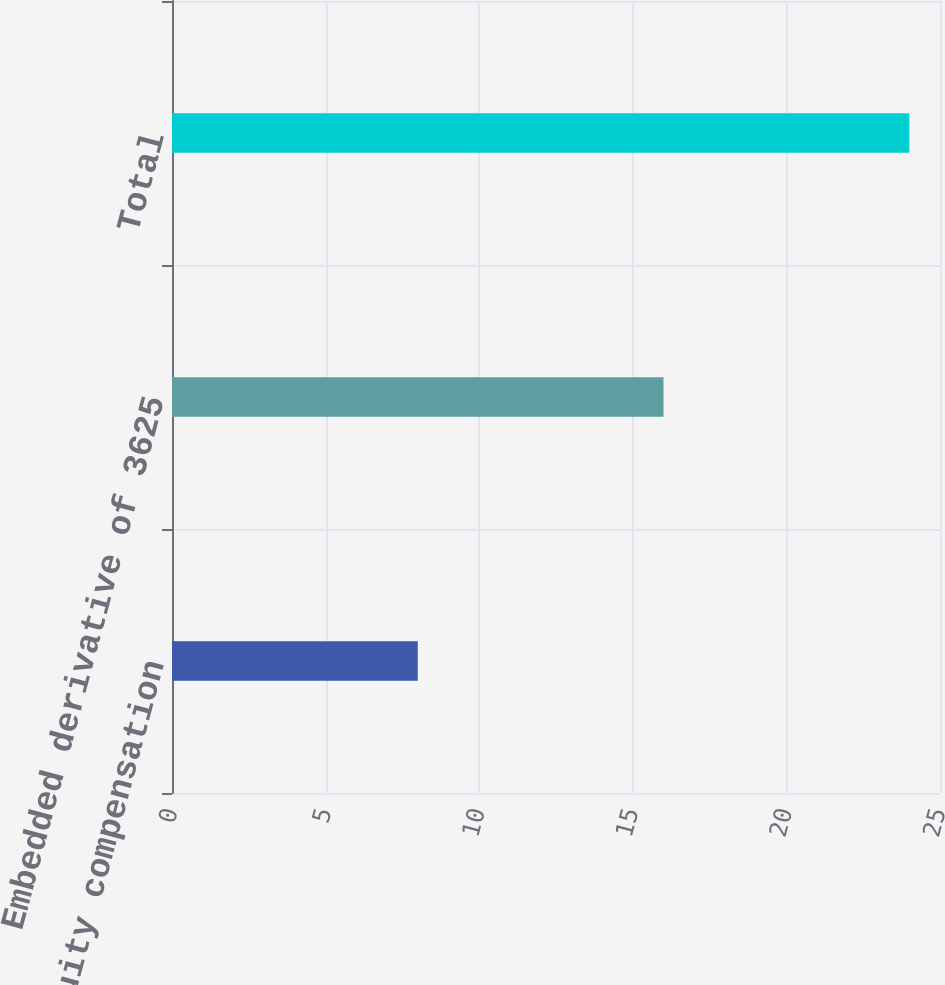Convert chart to OTSL. <chart><loc_0><loc_0><loc_500><loc_500><bar_chart><fcel>Equity compensation<fcel>Embedded derivative of 3625<fcel>Total<nl><fcel>8<fcel>16<fcel>24<nl></chart> 